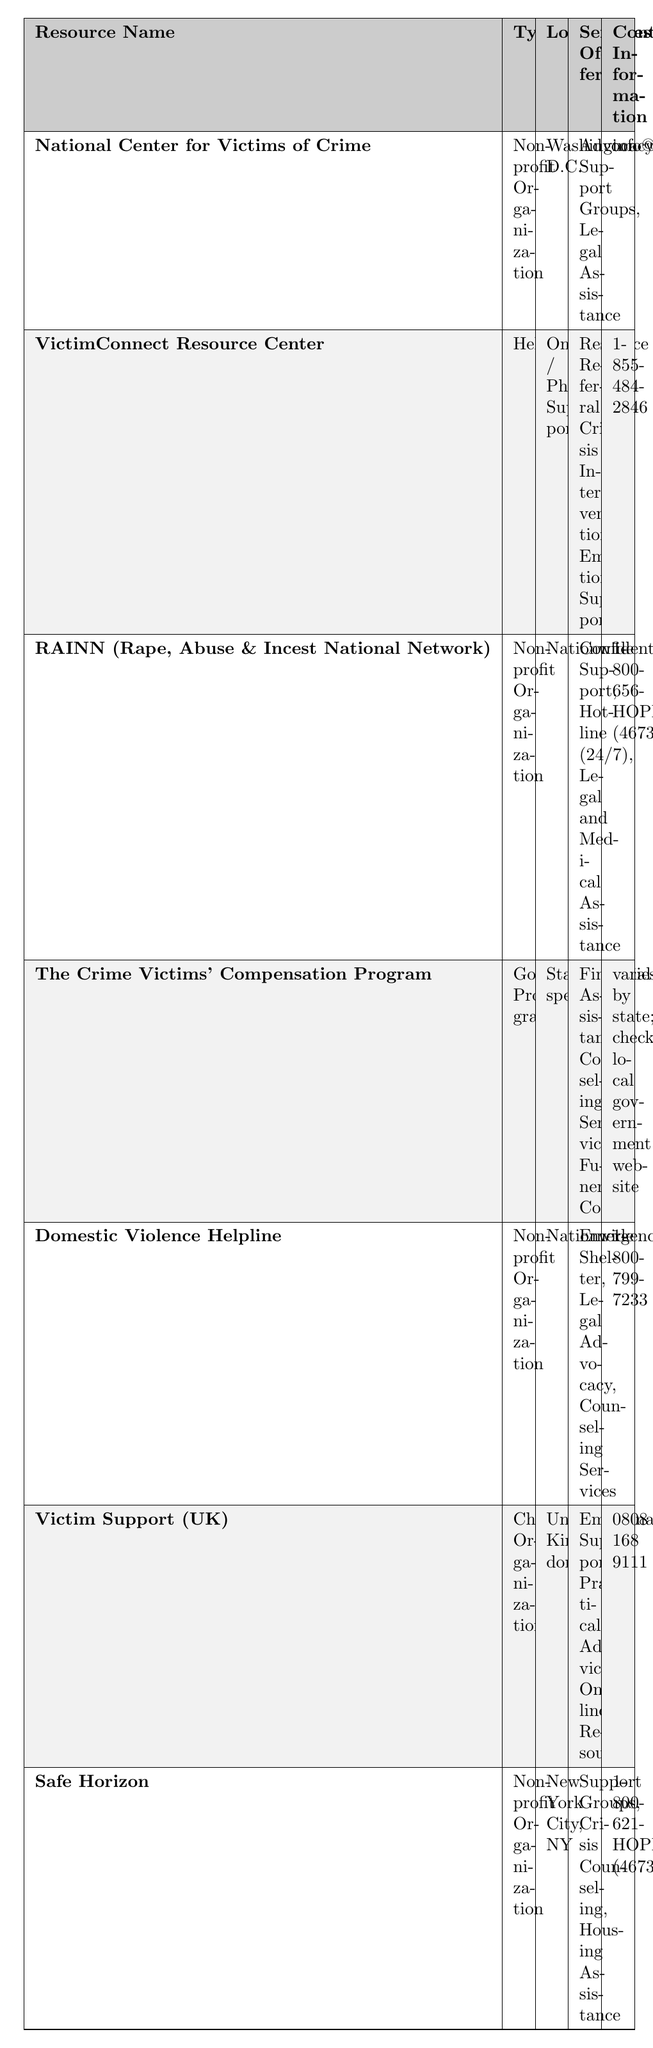What is the contact information for the National Center for Victims of Crime? The contact information for the National Center for Victims of Crime is listed as info@ncvc.org in the table.
Answer: info@ncvc.org How many types of resources are mentioned in the table? The table lists four types of resources: Non-profit Organization, Helpline, Government Program, and Charity Organization. Counting these gives us a total of four types.
Answer: 4 Is there a resource that offers 24/7 hotline support? Yes, RAINN (Rape, Abuse & Incest National Network) provides a hotline that is available 24/7 according to the table.
Answer: Yes What services does the Domestic Violence Helpline provide? According to the table, the Domestic Violence Helpline provides Emergency Shelter, Legal Advocacy, and Counseling Services as its offered services.
Answer: Emergency Shelter, Legal Advocacy, Counseling Services Which resource is located in New York City? The table indicates that Safe Horizon is located in New York City, NY.
Answer: Safe Horizon Are all resources available nationwide? No, not all resources are available nationwide. The table shows that The Crime Victims' Compensation Program is state-specific and that Victim Support is specifically located in the United Kingdom.
Answer: No What is the most common type of service offered among the resources? By analyzing the services offered for each resource, the most common services are Support Groups, Counseling Services, and Legal Assistance, which appear across multiple resources.
Answer: Support Groups, Counseling Services, Legal Assistance How many resources provide financial assistance? According to the table, only The Crime Victims' Compensation Program specifically mentions providing Financial Assistance. Therefore, there is 1 such resource.
Answer: 1 What is the location of the VictimConnect Resource Center? The VictimConnect Resource Center is located for Online / Phone Support as indicated in the table.
Answer: Online / Phone Support Which resource provides legal assistance and is a non-profit organization? The National Center for Victims of Crime provides both legal assistance and is classified as a non-profit organization according to the table.
Answer: National Center for Victims of Crime Is there a resource that offers practical advice? Yes, Victim Support (UK) offers Practical Advice as one of its services according to the table.
Answer: Yes 